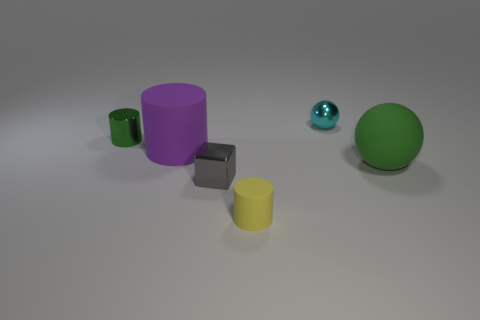There is a tiny cylinder left of the small block; what number of tiny yellow matte things are in front of it?
Your answer should be very brief. 1. Is the color of the large matte sphere the same as the metal cylinder?
Give a very brief answer. Yes. What number of other things are the same material as the green cylinder?
Provide a succinct answer. 2. The object to the right of the object that is behind the green metallic cylinder is what shape?
Your answer should be compact. Sphere. There is a green thing that is in front of the purple rubber cylinder; what is its size?
Make the answer very short. Large. Is the small green thing made of the same material as the tiny cube?
Ensure brevity in your answer.  Yes. What is the shape of the green object that is the same material as the tiny gray object?
Keep it short and to the point. Cylinder. Are there any other things of the same color as the small matte thing?
Your answer should be compact. No. There is a tiny metallic thing on the right side of the small gray metal block; what is its color?
Offer a very short reply. Cyan. Do the small cylinder behind the big green sphere and the large rubber sphere have the same color?
Offer a very short reply. Yes. 